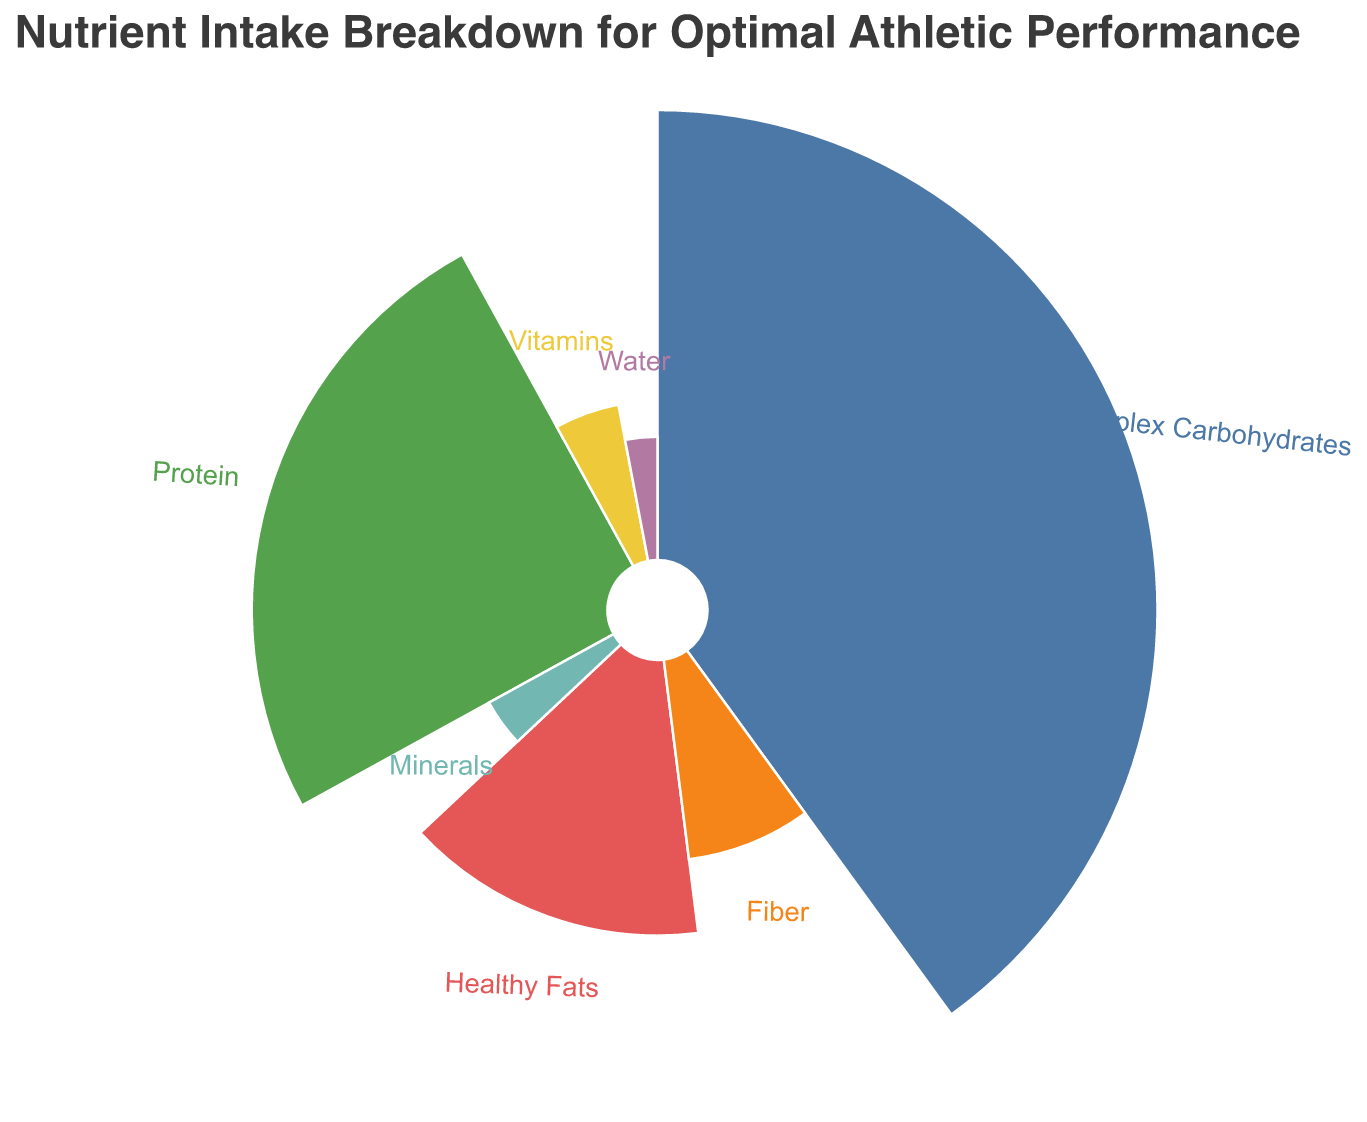Which nutrient has the highest percentage in the breakdown? By examining the figure, the nutrient with the largest segment is identified as Complex Carbohydrates.
Answer: Complex Carbohydrates What is the total percentage of Protein and Healthy Fats? From the figure, Protein is 25% and Healthy Fats is 15%. Adding these together gives 25% + 15% = 40%.
Answer: 40% Which nutrient takes up a smaller percentage, Vitamins or Minerals? According to the figure, Vitamins are 5% and Minerals are 4%. Since 4% is smaller than 5%, Minerals take up a smaller percentage.
Answer: Minerals How much greater is the percentage of Fiber than Water? Fiber is 8% and Water is 3%. The difference is 8% - 3% = 5%.
Answer: 5% List the nutrients in order from highest to lowest percentage. The figure shows the percentages as: Complex Carbohydrates (40%), Protein (25%), Healthy Fats (15%), Fiber (8%), Vitamins (5%), Minerals (4%), and Water (3%).
Answer: Complex Carbohydrates, Protein, Healthy Fats, Fiber, Vitamins, Minerals, Water What percentage of the nutrient intake is not coming from Protein, Complex Carbohydrates, and Healthy Fats? Summing the percentages of Protein, Complex Carbohydrates, and Healthy Fats gives 25% + 40% + 15% = 80%. The remaining percentage is 100% - 80% = 20%.
Answer: 20% If the percentage of Complex Carbohydrates were reduced by 10%, which nutrient would then have the highest percentage? Reducing Complex Carbohydrates by 10% brings it to 30%. Protein is then the highest at 25%.
Answer: Protein Identify the smallest segment in the polar chart. The figure shows the smallest segment as Water with 3%.
Answer: Water 